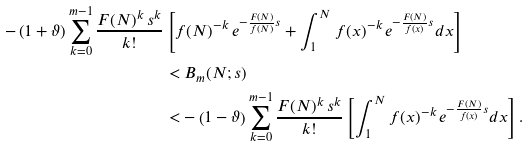Convert formula to latex. <formula><loc_0><loc_0><loc_500><loc_500>- \left ( 1 + \vartheta \right ) \sum _ { k = 0 } ^ { m - 1 } \frac { F ( N ) ^ { k } \, s ^ { k } } { k ! } & \left [ f ( N ) ^ { - k } \, e ^ { - \frac { F ( N ) } { f ( N ) } s } + \int _ { 1 } ^ { N } f ( x ) ^ { - k } \, e ^ { - \frac { F ( N ) } { f ( x ) } s } d x \right ] \\ & < B _ { m } ( N ; s ) \\ & < - \left ( 1 - \vartheta \right ) \sum _ { k = 0 } ^ { m - 1 } \frac { F ( N ) ^ { k } \, s ^ { k } } { k ! } \left [ \int _ { 1 } ^ { N } f ( x ) ^ { - k } \, e ^ { - \frac { F ( N ) } { f ( x ) } s } d x \right ] .</formula> 